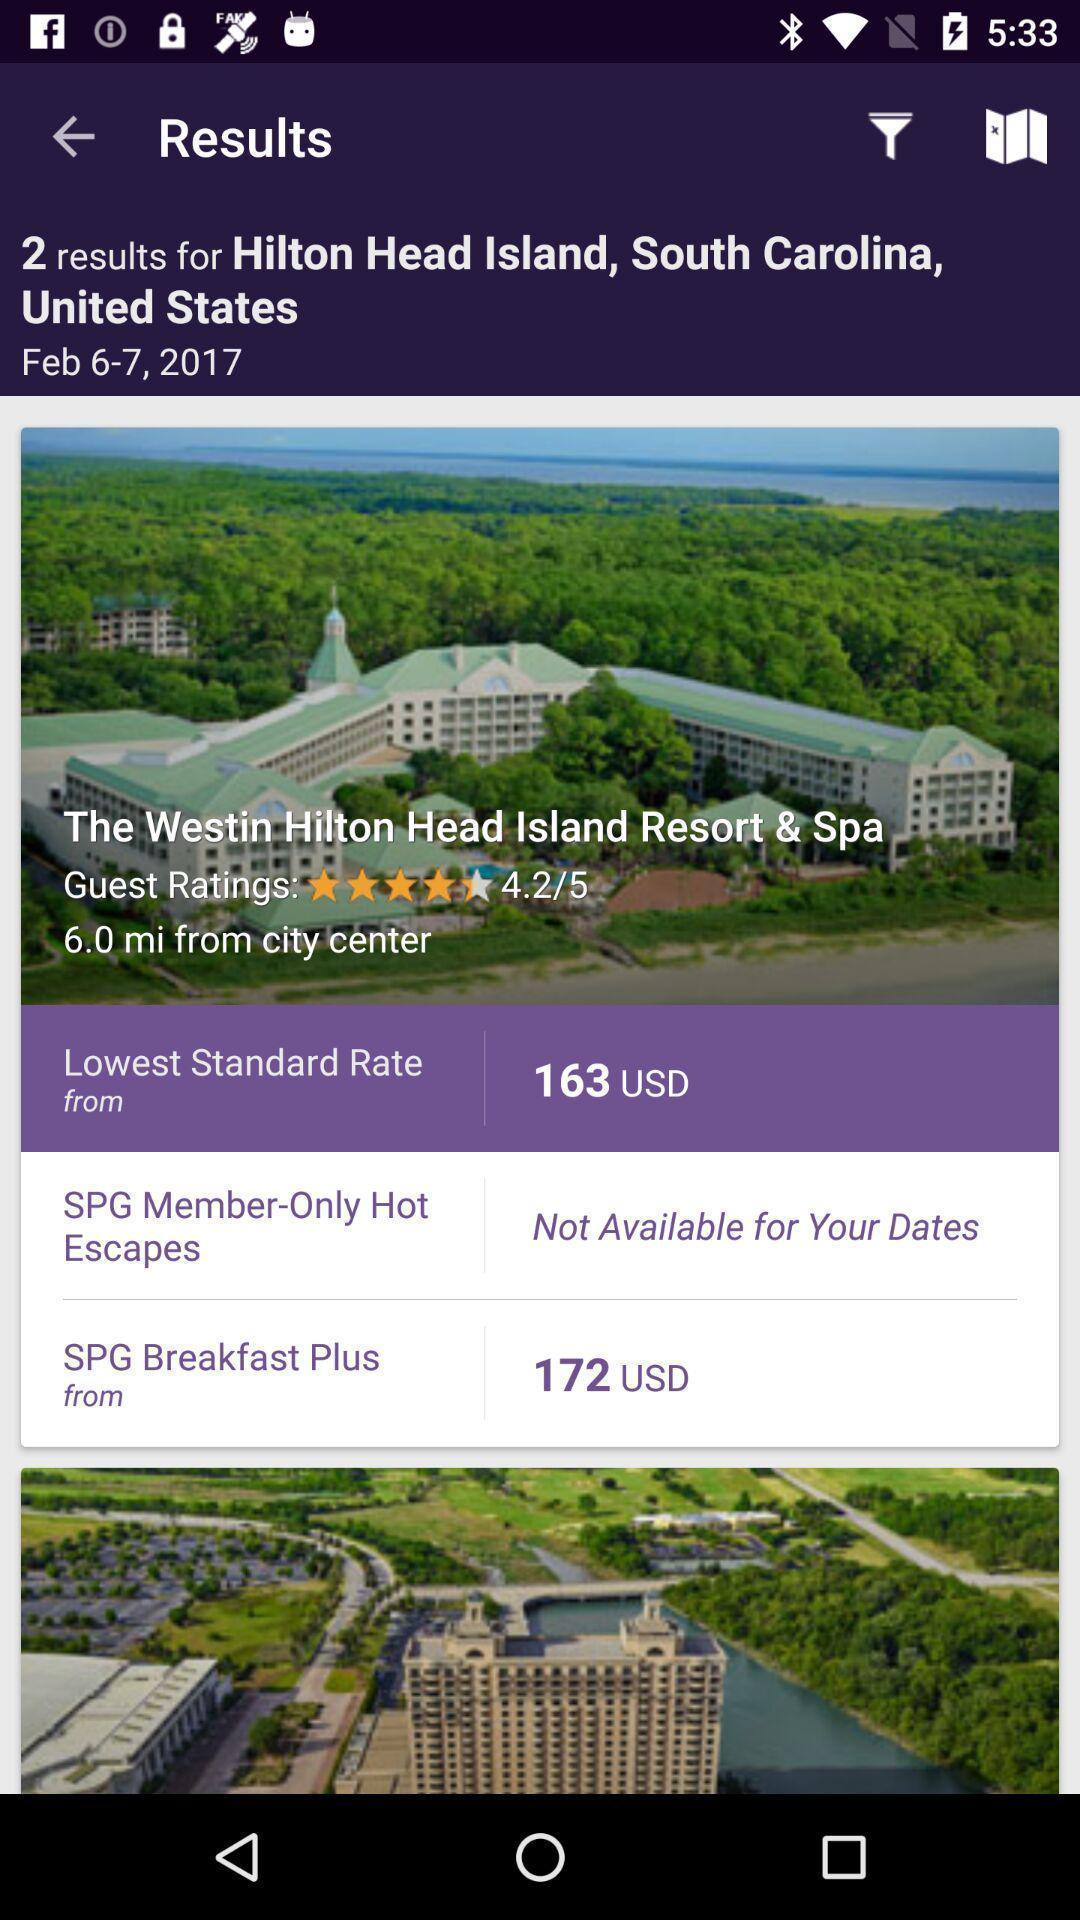Give me a summary of this screen capture. Screen showing the image of a location. 